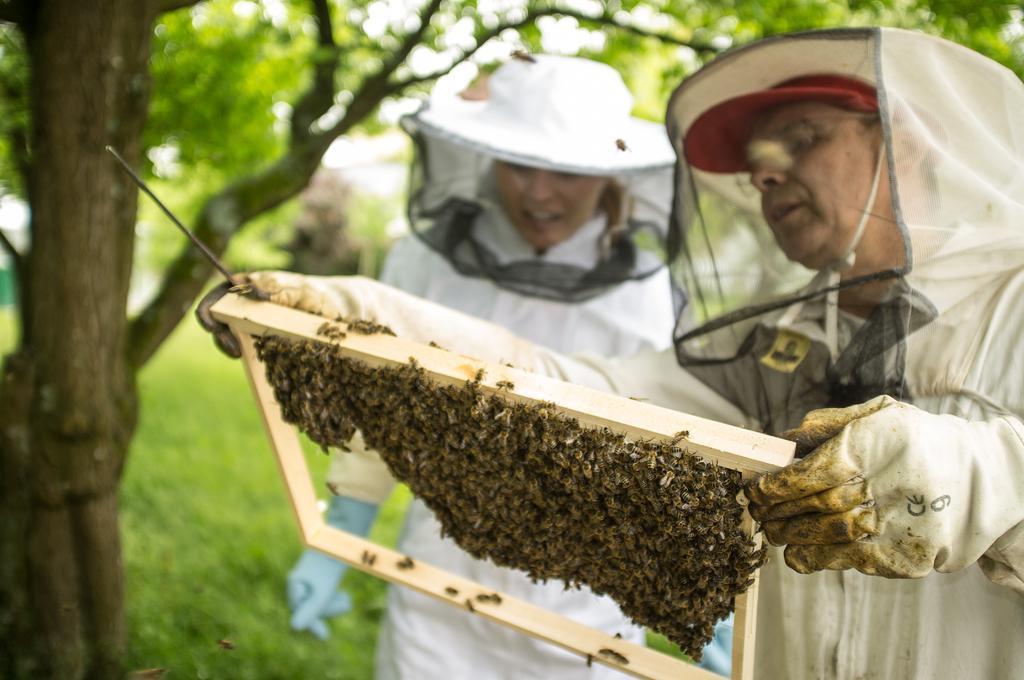How would you summarize this image in a sentence or two? Here I can see two persons wearing white color dresses, masks to their faces, standing and holding a wooden object which seems to be a honeycomb. There are many honey bees to it. In the background there are many trees. At the bottom, I can see the grass. 